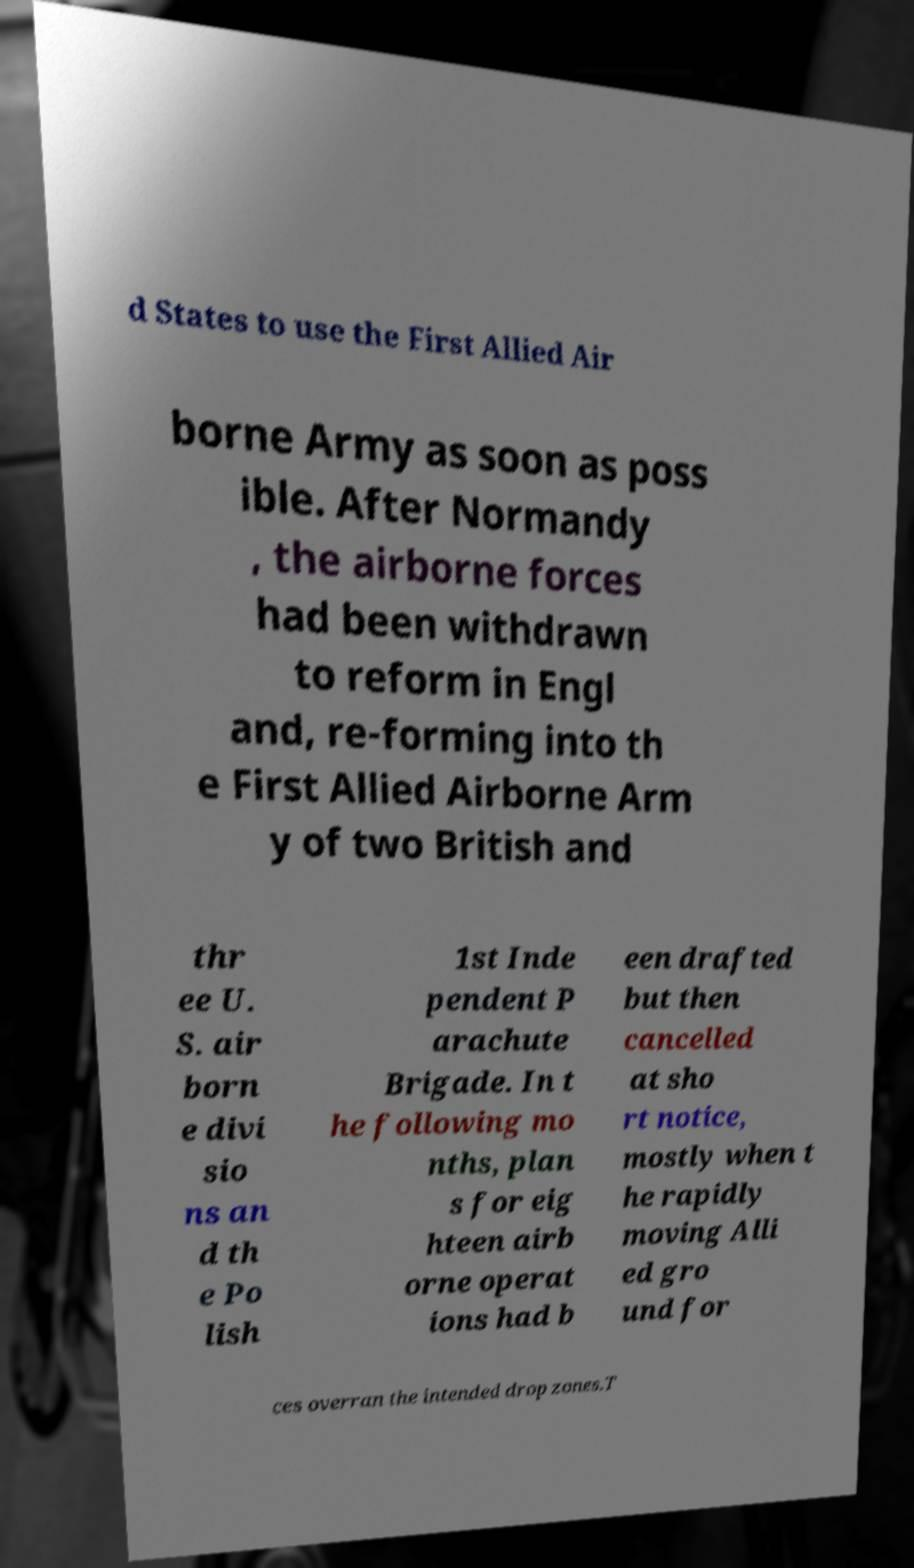Can you read and provide the text displayed in the image?This photo seems to have some interesting text. Can you extract and type it out for me? d States to use the First Allied Air borne Army as soon as poss ible. After Normandy , the airborne forces had been withdrawn to reform in Engl and, re-forming into th e First Allied Airborne Arm y of two British and thr ee U. S. air born e divi sio ns an d th e Po lish 1st Inde pendent P arachute Brigade. In t he following mo nths, plan s for eig hteen airb orne operat ions had b een drafted but then cancelled at sho rt notice, mostly when t he rapidly moving Alli ed gro und for ces overran the intended drop zones.T 